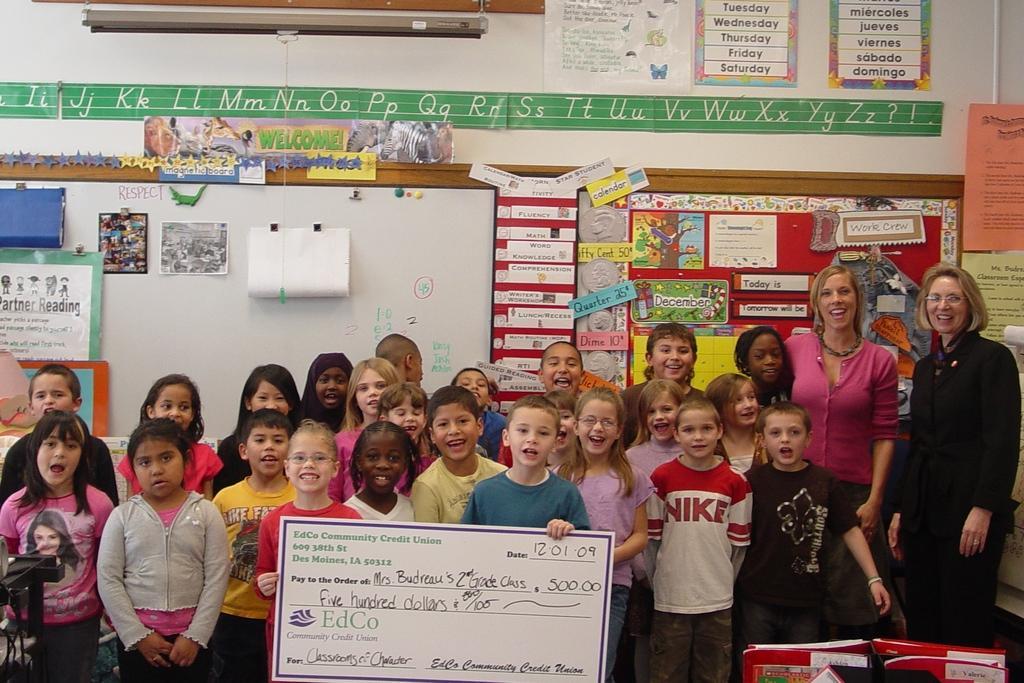Please provide a concise description of this image. In this image there are group of persons standing, there are persons holding a board, there is text on the board, there is an object truncated towards the bottom of the image, there are object truncated towards the left of the image, there is a board behind the persons, there are objects on the board, there is the wall, there are objects on the wall, there are objects truncated towards the right of the image. 